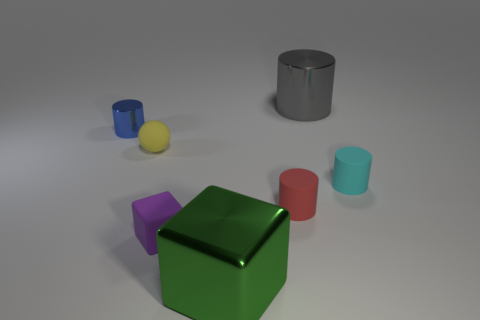Add 2 gray metal objects. How many objects exist? 9 Subtract all blocks. How many objects are left? 5 Subtract all red cylinders. How many cylinders are left? 3 Subtract 1 spheres. How many spheres are left? 0 Subtract all yellow cylinders. Subtract all purple spheres. How many cylinders are left? 4 Subtract all purple cubes. How many green cylinders are left? 0 Subtract all small cyan objects. Subtract all metal blocks. How many objects are left? 5 Add 3 small metal cylinders. How many small metal cylinders are left? 4 Add 4 large gray metal cylinders. How many large gray metal cylinders exist? 5 Subtract all big gray cylinders. How many cylinders are left? 3 